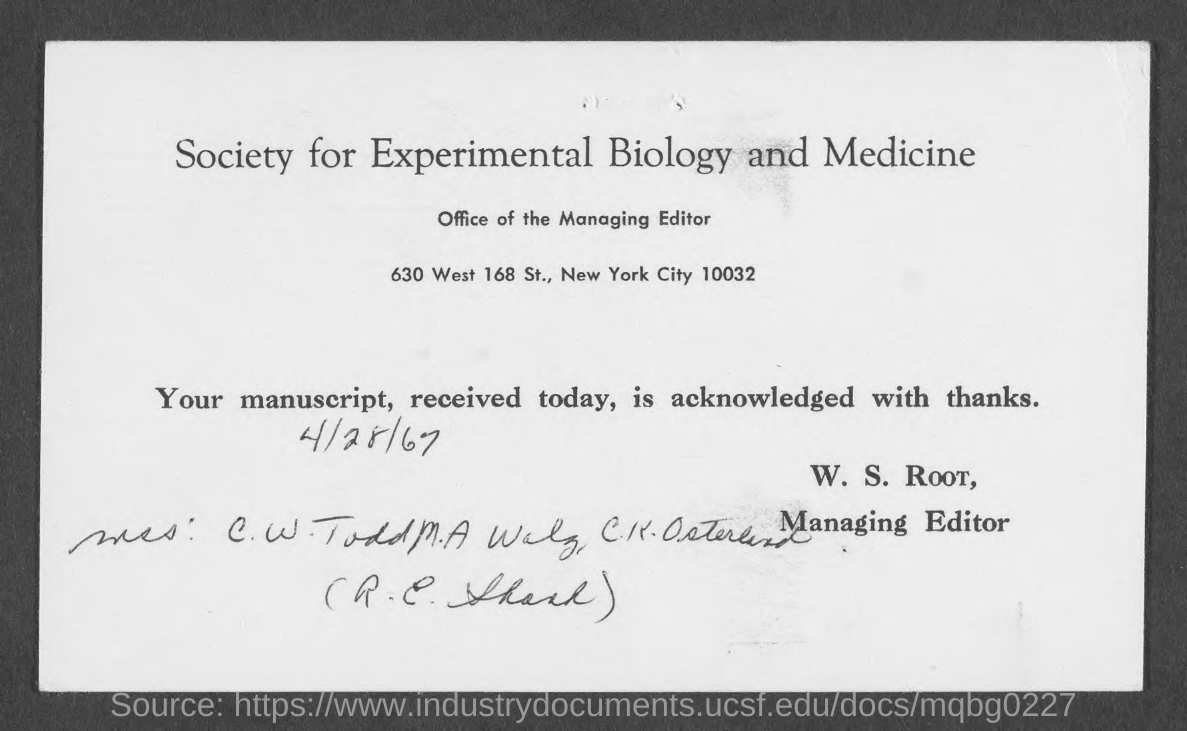What is the received date of the manuscript?
Give a very brief answer. 4/28/67. 